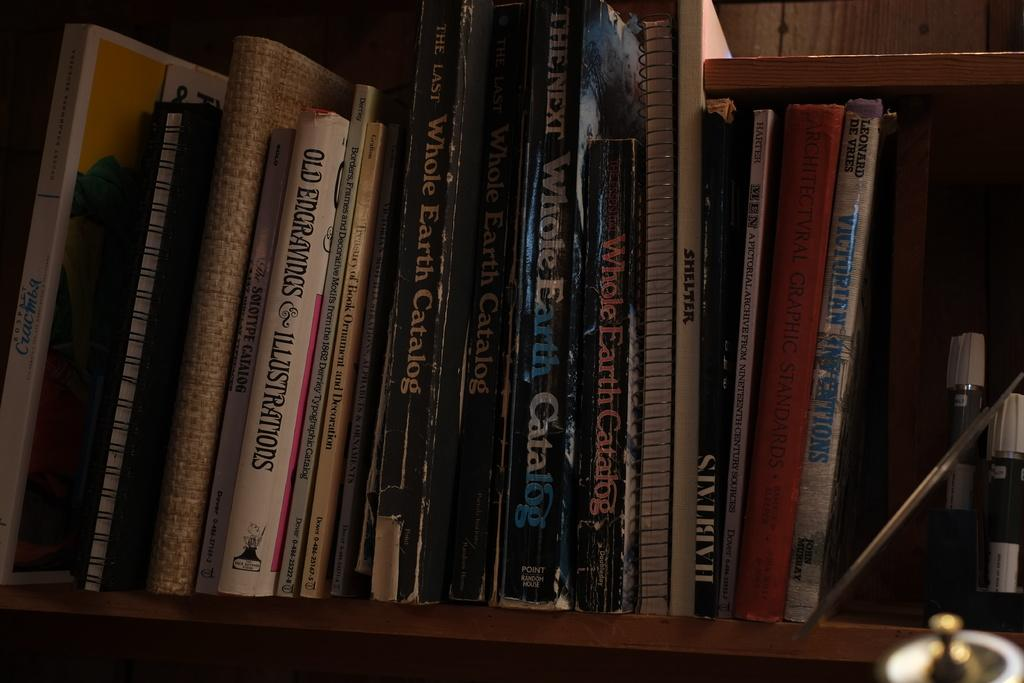<image>
Render a clear and concise summary of the photo. On a bookshelf, multiple versions of the Whole Earth Catalog exist. 